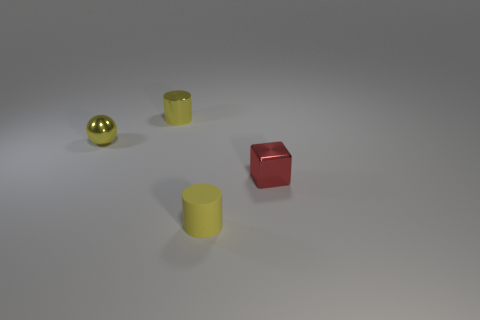The yellow metallic cylinder is what size?
Your answer should be very brief. Small. What material is the block?
Ensure brevity in your answer.  Metal. What number of things are either red shiny cubes or small yellow metal things?
Make the answer very short. 3. What shape is the rubber thing that is the same color as the shiny ball?
Keep it short and to the point. Cylinder. There is a yellow thing that is both right of the yellow sphere and behind the tiny yellow rubber cylinder; how big is it?
Keep it short and to the point. Small. What number of big cyan blocks are there?
Give a very brief answer. 0. How many spheres are either rubber objects or tiny red metal things?
Offer a terse response. 0. How many yellow objects are on the right side of the shiny thing that is behind the small yellow object that is left of the shiny cylinder?
Provide a succinct answer. 1. What color is the metallic sphere that is the same size as the red metal object?
Offer a very short reply. Yellow. What number of other objects are there of the same color as the tiny shiny cylinder?
Keep it short and to the point. 2. 